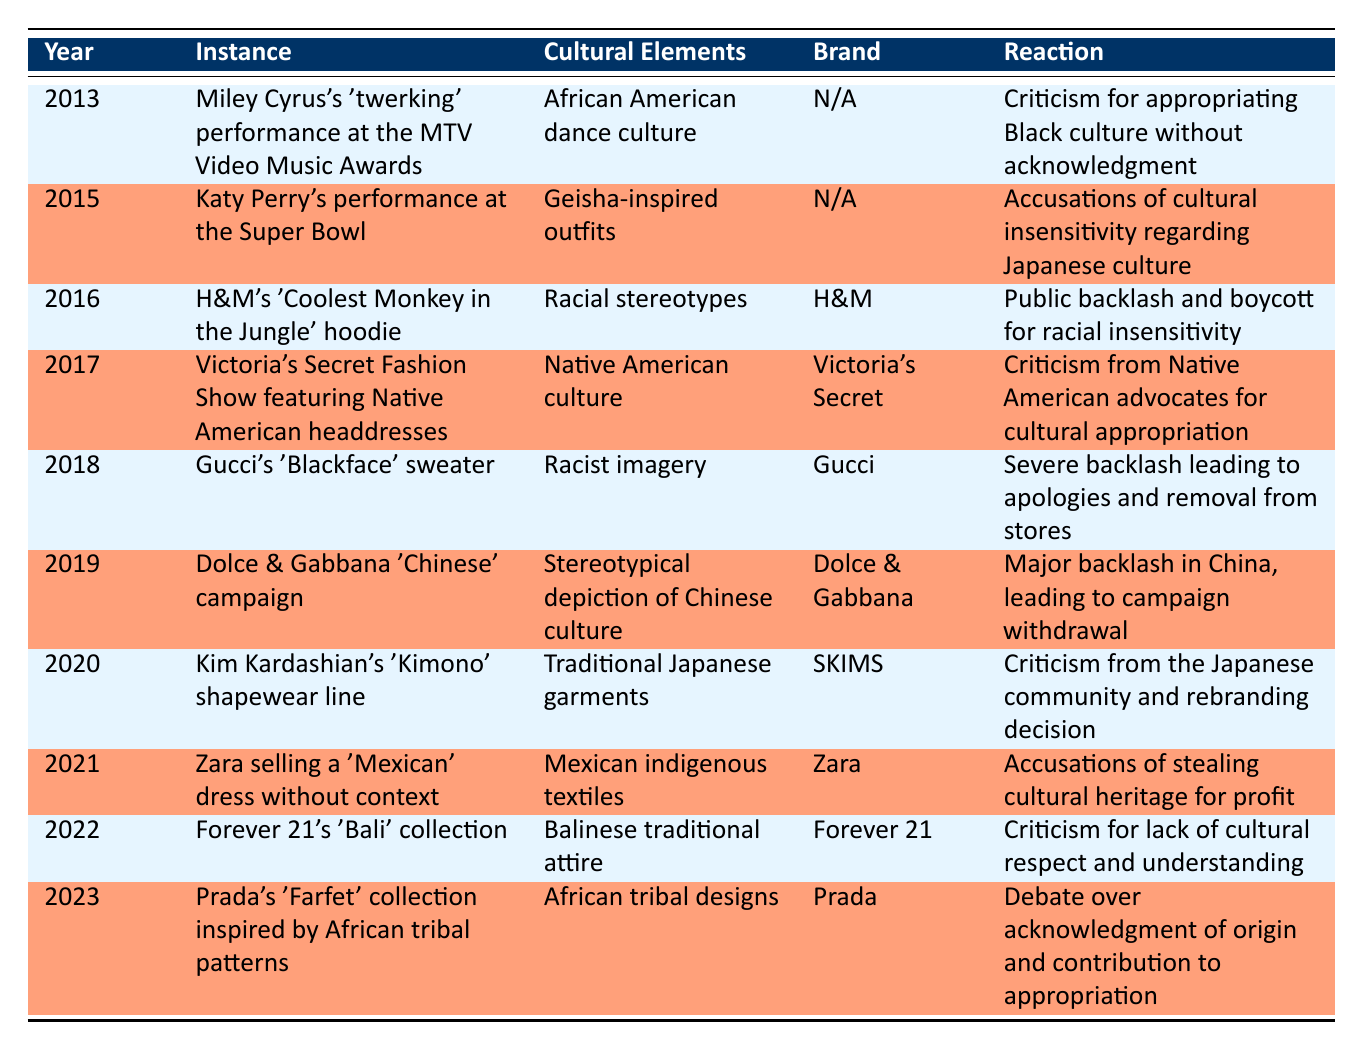What was the cultural element involved in Miley Cyrus's 2013 performance at the MTV Video Music Awards? According to the table, the cultural element involved in Miley Cyrus's performance was African American dance culture.
Answer: African American dance culture Which brand was associated with the 'Coolest Monkey in the Jungle' hoodie incident? The table specifies that the brand associated with this incident is H&M.
Answer: H&M Did Zara face accusations related to cultural appropriation for selling a 'Mexican' dress? The table indicates that Zara did face accusations of stealing cultural heritage for profit, thus the answer is yes.
Answer: Yes In what year did Gucci release a sweater that was criticized for racist imagery? The table shows that Gucci's 'Blackface' sweater was released in 2018, as indicated in the year column.
Answer: 2018 How many instances of cultural appropriation involved fashion brands from 2020 onwards? From the table, the instances from 2020 onward are: Kim Kardashian's shapewear line (2020), Zara's dress (2021), Forever 21's collection (2022), and Prada's collection (2023), giving us a total of 4 instances.
Answer: 4 What reactions followed the 'Chinese' campaign by Dolce & Gabbana in 2019? According to the table, the reaction was a major backlash in China, which led to the withdrawal of the campaign.
Answer: Major backlash leading to campaign withdrawal Which event or instance from the table had the most severe backlash? Assessing the table, Gucci's 'Blackface' sweater in 2018 noted severe backlash leading to apologies and removal from stores, making it the instance with the most severe reaction.
Answer: Gucci's 'Blackface' sweater in 2018 What can be inferred about the overall trend of cultural appropriation in fashion from the years listed? Analyzing the table, one can infer that over the years, instances of cultural appropriation in fashion have prompted increasing public awareness and backlash, as reactions have progressively become more vocal and organized.
Answer: Increased public awareness and backlash 